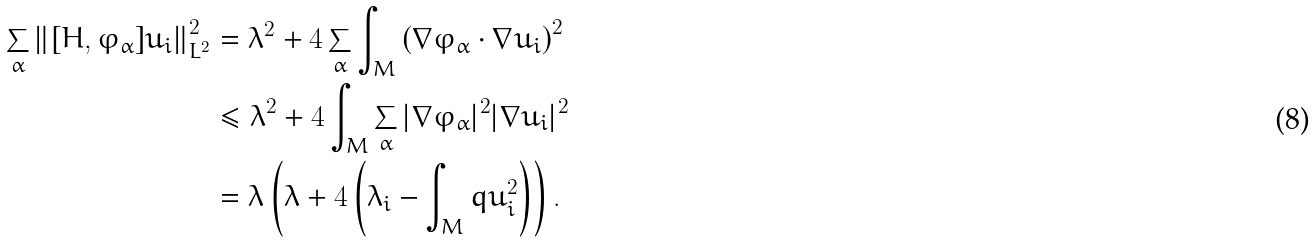<formula> <loc_0><loc_0><loc_500><loc_500>\sum _ { \alpha } \left \| [ H , \varphi _ { \alpha } ] u _ { i } \right \| _ { L ^ { 2 } } ^ { 2 } & = \lambda ^ { 2 } + 4 \sum _ { \alpha } \int _ { M } \left ( \nabla { \varphi _ { \alpha } } \cdot \nabla { u _ { i } } \right ) ^ { 2 } \\ & \leq \lambda ^ { 2 } + 4 \int _ { M } \sum _ { \alpha } | \nabla { \varphi _ { \alpha } } | ^ { 2 } | \nabla { u _ { i } } | ^ { 2 } \\ & = \lambda \left ( \lambda + 4 \left ( \lambda _ { i } - \int _ { M } q u _ { i } ^ { 2 } \right ) \right ) .</formula> 